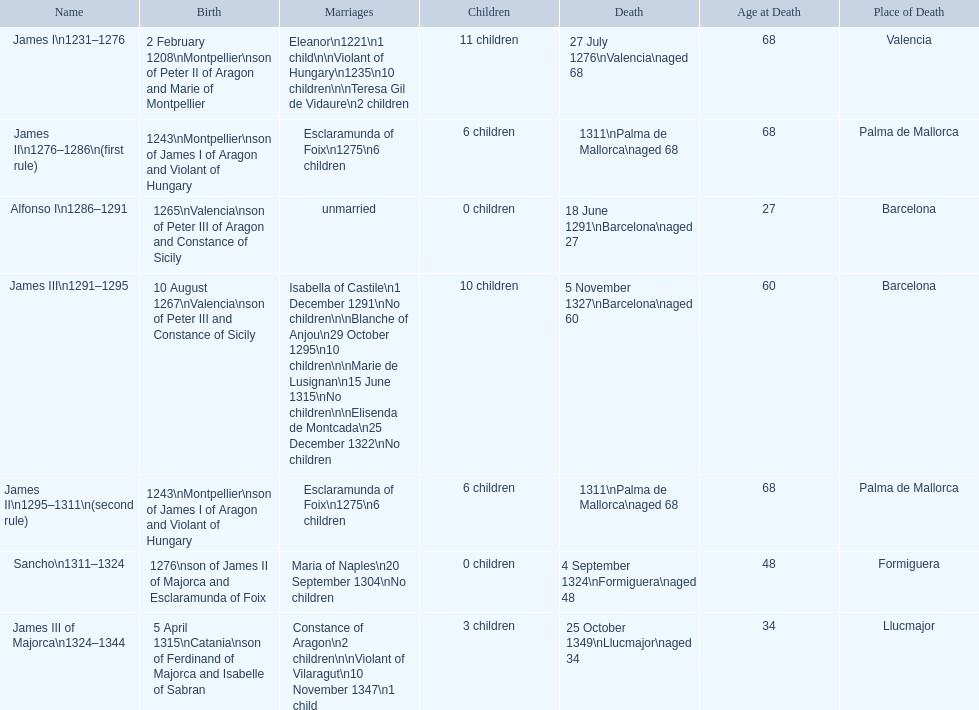Parse the table in full. {'header': ['Name', 'Birth', 'Marriages', 'Children', 'Death', 'Age at Death', 'Place of Death'], 'rows': [['James I\\n1231–1276', '2 February 1208\\nMontpellier\\nson of Peter II of Aragon and Marie of Montpellier', 'Eleanor\\n1221\\n1 child\\n\\nViolant of Hungary\\n1235\\n10 children\\n\\nTeresa Gil de Vidaure\\n2 children', '11 children', '27 July 1276\\nValencia\\naged 68', '68', 'Valencia'], ['James II\\n1276–1286\\n(first rule)', '1243\\nMontpellier\\nson of James I of Aragon and Violant of Hungary', 'Esclaramunda of Foix\\n1275\\n6 children', '6 children', '1311\\nPalma de Mallorca\\naged 68', '68', 'Palma de Mallorca'], ['Alfonso I\\n1286–1291', '1265\\nValencia\\nson of Peter III of Aragon and Constance of Sicily', 'unmarried', '0 children', '18 June 1291\\nBarcelona\\naged 27', '27', 'Barcelona'], ['James III\\n1291–1295', '10 August 1267\\nValencia\\nson of Peter III and Constance of Sicily', 'Isabella of Castile\\n1 December 1291\\nNo children\\n\\nBlanche of Anjou\\n29 October 1295\\n10 children\\n\\nMarie de Lusignan\\n15 June 1315\\nNo children\\n\\nElisenda de Montcada\\n25 December 1322\\nNo children', '10 children', '5 November 1327\\nBarcelona\\naged 60', '60', 'Barcelona'], ['James II\\n1295–1311\\n(second rule)', '1243\\nMontpellier\\nson of James I of Aragon and Violant of Hungary', 'Esclaramunda of Foix\\n1275\\n6 children', '6 children', '1311\\nPalma de Mallorca\\naged 68', '68', 'Palma de Mallorca'], ['Sancho\\n1311–1324', '1276\\nson of James II of Majorca and Esclaramunda of Foix', 'Maria of Naples\\n20 September 1304\\nNo children', '0 children', '4 September 1324\\nFormiguera\\naged 48', '48', 'Formiguera'], ['James III of Majorca\\n1324–1344', '5 April 1315\\nCatania\\nson of Ferdinand of Majorca and Isabelle of Sabran', 'Constance of Aragon\\n2 children\\n\\nViolant of Vilaragut\\n10 November 1347\\n1 child', '3 children', '25 October 1349\\nLlucmajor\\naged 34', '34', 'Llucmajor']]} James i and james ii both died at what age? 68. 